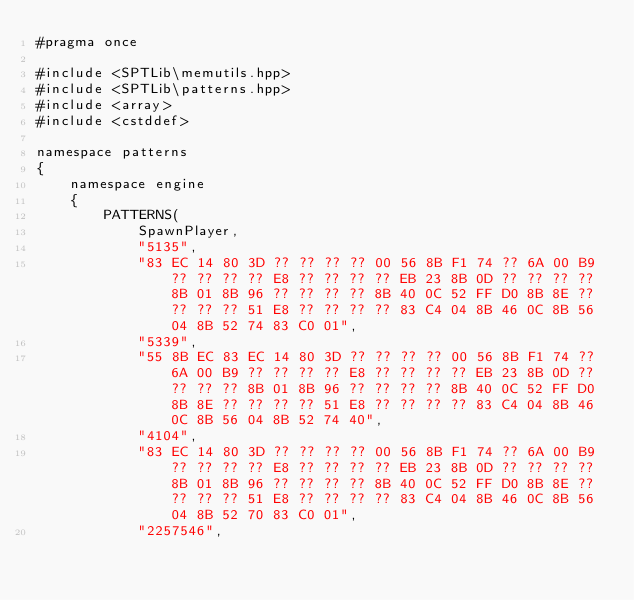<code> <loc_0><loc_0><loc_500><loc_500><_C++_>#pragma once

#include <SPTLib\memutils.hpp>
#include <SPTLib\patterns.hpp>
#include <array>
#include <cstddef>

namespace patterns
{
	namespace engine
	{
		PATTERNS(
		    SpawnPlayer,
		    "5135",
		    "83 EC 14 80 3D ?? ?? ?? ?? 00 56 8B F1 74 ?? 6A 00 B9 ?? ?? ?? ?? E8 ?? ?? ?? ?? EB 23 8B 0D ?? ?? ?? ?? 8B 01 8B 96 ?? ?? ?? ?? 8B 40 0C 52 FF D0 8B 8E ?? ?? ?? ?? 51 E8 ?? ?? ?? ?? 83 C4 04 8B 46 0C 8B 56 04 8B 52 74 83 C0 01",
		    "5339",
		    "55 8B EC 83 EC 14 80 3D ?? ?? ?? ?? 00 56 8B F1 74 ?? 6A 00 B9 ?? ?? ?? ?? E8 ?? ?? ?? ?? EB 23 8B 0D ?? ?? ?? ?? 8B 01 8B 96 ?? ?? ?? ?? 8B 40 0C 52 FF D0 8B 8E ?? ?? ?? ?? 51 E8 ?? ?? ?? ?? 83 C4 04 8B 46 0C 8B 56 04 8B 52 74 40",
		    "4104",
		    "83 EC 14 80 3D ?? ?? ?? ?? 00 56 8B F1 74 ?? 6A 00 B9 ?? ?? ?? ?? E8 ?? ?? ?? ?? EB 23 8B 0D ?? ?? ?? ?? 8B 01 8B 96 ?? ?? ?? ?? 8B 40 0C 52 FF D0 8B 8E ?? ?? ?? ?? 51 E8 ?? ?? ?? ?? 83 C4 04 8B 46 0C 8B 56 04 8B 52 70 83 C0 01",
		    "2257546",</code> 